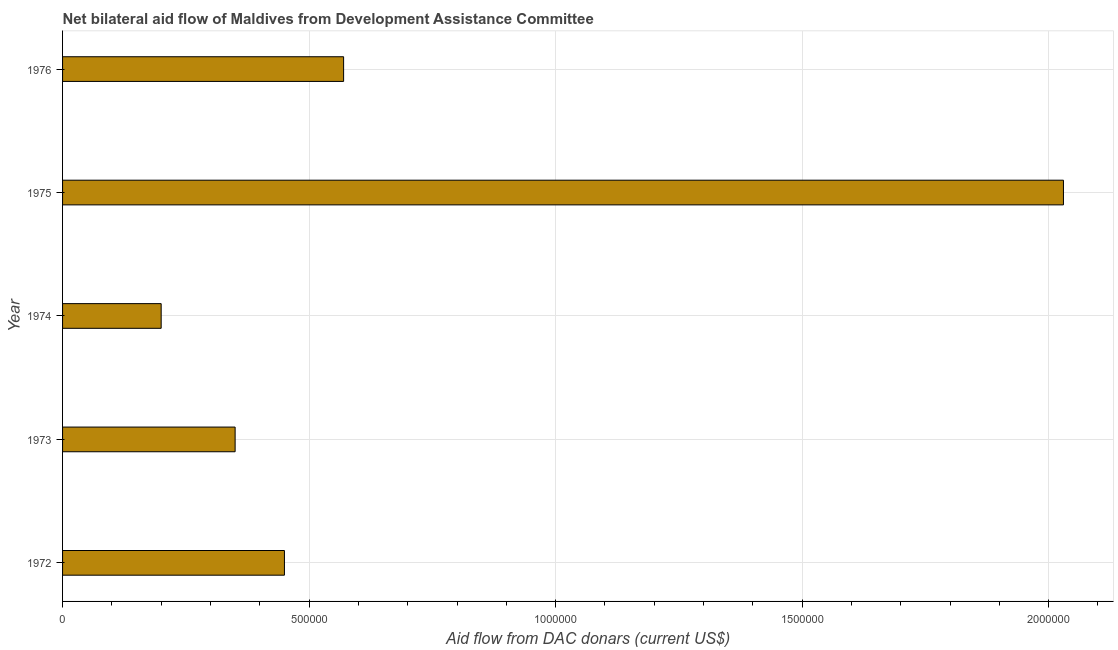Does the graph contain grids?
Keep it short and to the point. Yes. What is the title of the graph?
Ensure brevity in your answer.  Net bilateral aid flow of Maldives from Development Assistance Committee. What is the label or title of the X-axis?
Ensure brevity in your answer.  Aid flow from DAC donars (current US$). Across all years, what is the maximum net bilateral aid flows from dac donors?
Provide a short and direct response. 2.03e+06. In which year was the net bilateral aid flows from dac donors maximum?
Your answer should be very brief. 1975. In which year was the net bilateral aid flows from dac donors minimum?
Your response must be concise. 1974. What is the sum of the net bilateral aid flows from dac donors?
Provide a short and direct response. 3.60e+06. What is the difference between the net bilateral aid flows from dac donors in 1972 and 1975?
Your answer should be very brief. -1.58e+06. What is the average net bilateral aid flows from dac donors per year?
Give a very brief answer. 7.20e+05. What is the median net bilateral aid flows from dac donors?
Provide a short and direct response. 4.50e+05. What is the ratio of the net bilateral aid flows from dac donors in 1972 to that in 1974?
Your response must be concise. 2.25. Is the net bilateral aid flows from dac donors in 1972 less than that in 1974?
Offer a very short reply. No. Is the difference between the net bilateral aid flows from dac donors in 1973 and 1974 greater than the difference between any two years?
Your answer should be very brief. No. What is the difference between the highest and the second highest net bilateral aid flows from dac donors?
Offer a very short reply. 1.46e+06. What is the difference between the highest and the lowest net bilateral aid flows from dac donors?
Give a very brief answer. 1.83e+06. How many bars are there?
Provide a short and direct response. 5. Are the values on the major ticks of X-axis written in scientific E-notation?
Your answer should be compact. No. What is the Aid flow from DAC donars (current US$) in 1973?
Offer a terse response. 3.50e+05. What is the Aid flow from DAC donars (current US$) in 1975?
Make the answer very short. 2.03e+06. What is the Aid flow from DAC donars (current US$) in 1976?
Keep it short and to the point. 5.70e+05. What is the difference between the Aid flow from DAC donars (current US$) in 1972 and 1973?
Provide a short and direct response. 1.00e+05. What is the difference between the Aid flow from DAC donars (current US$) in 1972 and 1975?
Offer a terse response. -1.58e+06. What is the difference between the Aid flow from DAC donars (current US$) in 1973 and 1975?
Provide a succinct answer. -1.68e+06. What is the difference between the Aid flow from DAC donars (current US$) in 1973 and 1976?
Your response must be concise. -2.20e+05. What is the difference between the Aid flow from DAC donars (current US$) in 1974 and 1975?
Offer a very short reply. -1.83e+06. What is the difference between the Aid flow from DAC donars (current US$) in 1974 and 1976?
Keep it short and to the point. -3.70e+05. What is the difference between the Aid flow from DAC donars (current US$) in 1975 and 1976?
Your answer should be very brief. 1.46e+06. What is the ratio of the Aid flow from DAC donars (current US$) in 1972 to that in 1973?
Provide a succinct answer. 1.29. What is the ratio of the Aid flow from DAC donars (current US$) in 1972 to that in 1974?
Your response must be concise. 2.25. What is the ratio of the Aid flow from DAC donars (current US$) in 1972 to that in 1975?
Your answer should be compact. 0.22. What is the ratio of the Aid flow from DAC donars (current US$) in 1972 to that in 1976?
Your answer should be compact. 0.79. What is the ratio of the Aid flow from DAC donars (current US$) in 1973 to that in 1975?
Give a very brief answer. 0.17. What is the ratio of the Aid flow from DAC donars (current US$) in 1973 to that in 1976?
Make the answer very short. 0.61. What is the ratio of the Aid flow from DAC donars (current US$) in 1974 to that in 1975?
Give a very brief answer. 0.1. What is the ratio of the Aid flow from DAC donars (current US$) in 1974 to that in 1976?
Your answer should be compact. 0.35. What is the ratio of the Aid flow from DAC donars (current US$) in 1975 to that in 1976?
Your response must be concise. 3.56. 